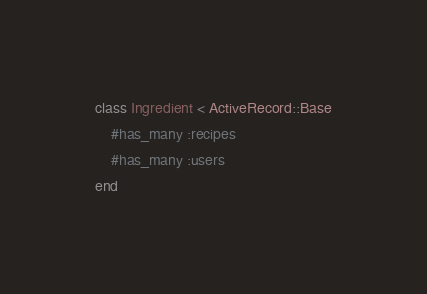<code> <loc_0><loc_0><loc_500><loc_500><_Ruby_>class Ingredient < ActiveRecord::Base
    #has_many :recipes
    #has_many :users
end </code> 